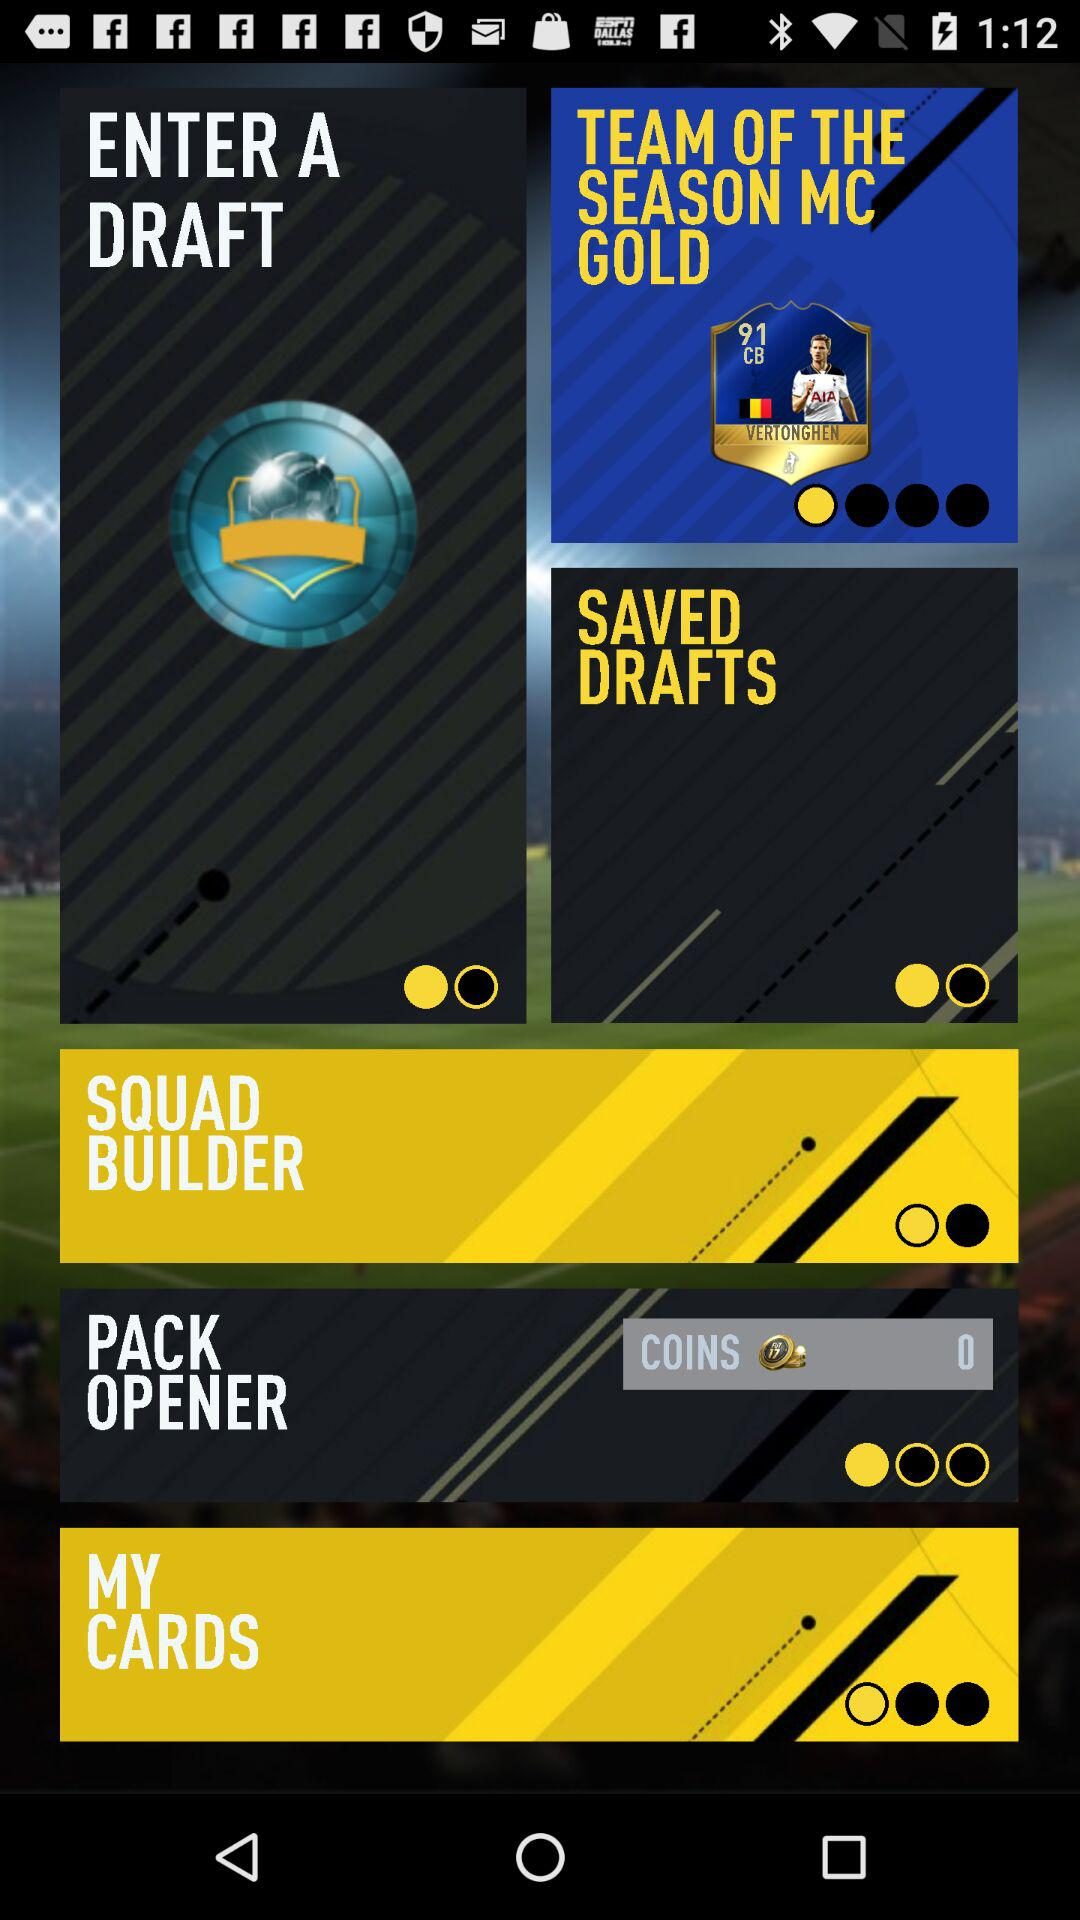How many coins are there? There are 0 coins. 